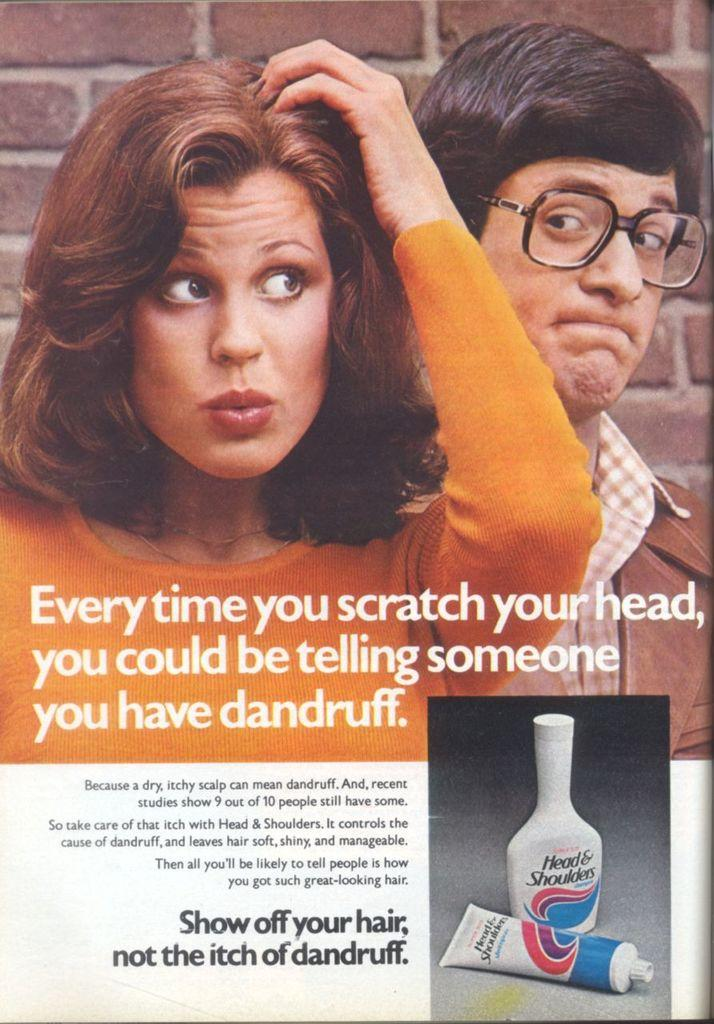<image>
Share a concise interpretation of the image provided. An advertisement for Head and shoulders dandruff shampoo 